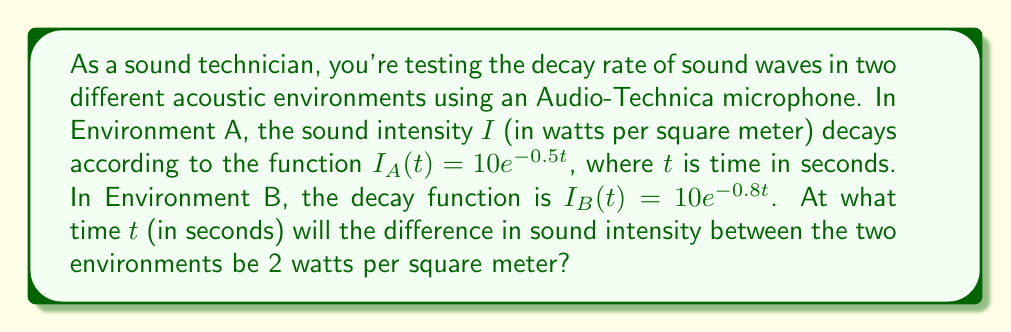Can you solve this math problem? Let's approach this step-by-step:

1) We need to find the time $t$ when the difference between $I_A(t)$ and $I_B(t)$ is 2.
   This can be expressed as:
   $$I_A(t) - I_B(t) = 2$$

2) Substituting the given functions:
   $$10e^{-0.5t} - 10e^{-0.8t} = 2$$

3) Factor out 10:
   $$10(e^{-0.5t} - e^{-0.8t}) = 2$$

4) Divide both sides by 10:
   $$e^{-0.5t} - e^{-0.8t} = 0.2$$

5) This equation cannot be solved algebraically. We need to use numerical methods or graphing to find the solution.

6) Using a graphing calculator or computer software, we can find that this equation is satisfied when $t \approx 2.877$ seconds.

7) We can verify this solution:
   At $t = 2.877$:
   $I_A(2.877) = 10e^{-0.5(2.877)} \approx 2.3935$
   $I_B(2.877) = 10e^{-0.8(2.877)} \approx 0.3935$
   
   $I_A(2.877) - I_B(2.877) \approx 2.3935 - 0.3935 = 2$
Answer: $2.877$ seconds 